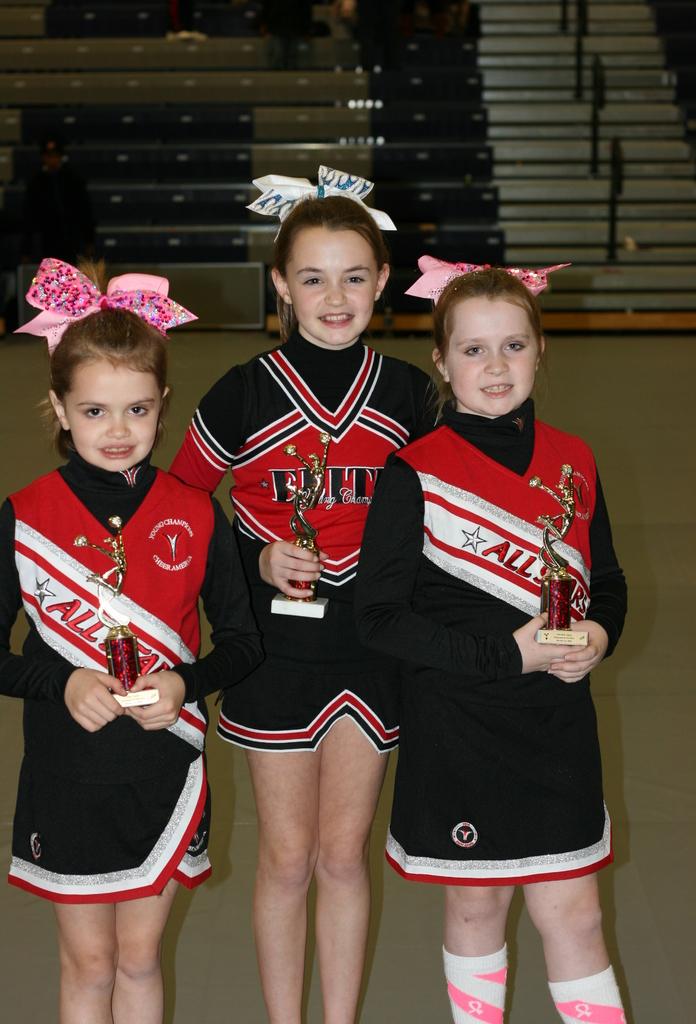What word is listed on the girl on the rights shirt?
Make the answer very short. All. Are they all stars?
Give a very brief answer. Yes. 